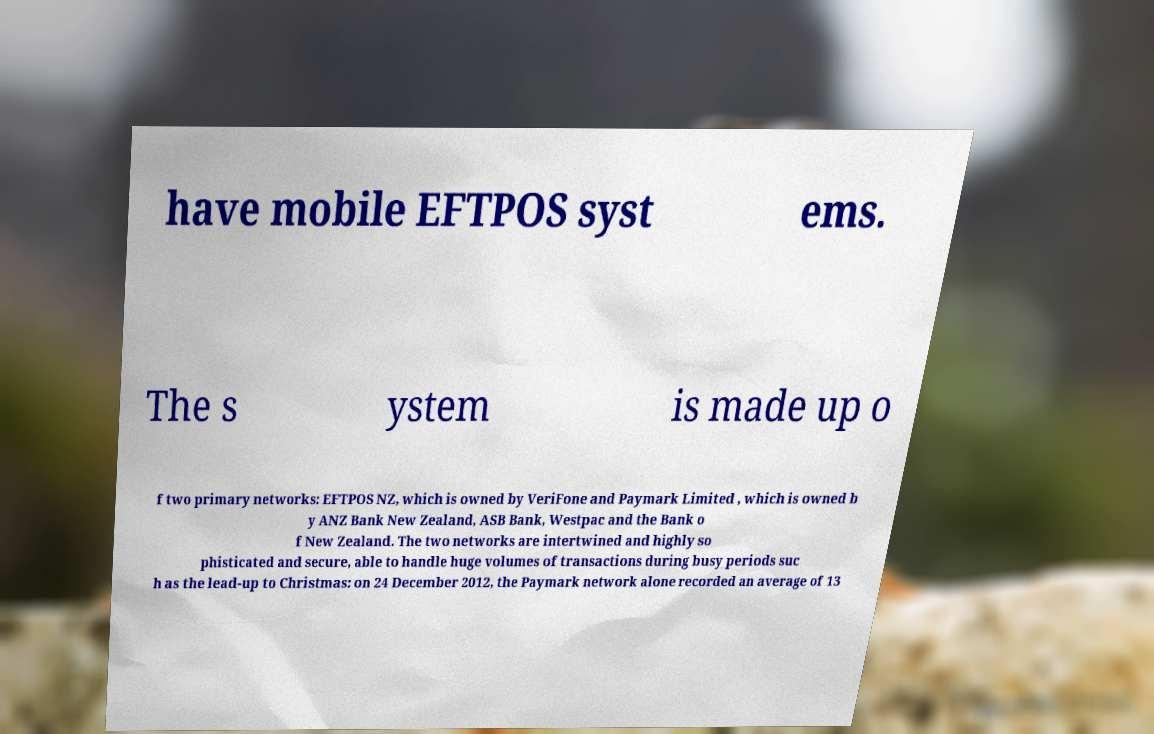Can you read and provide the text displayed in the image?This photo seems to have some interesting text. Can you extract and type it out for me? have mobile EFTPOS syst ems. The s ystem is made up o f two primary networks: EFTPOS NZ, which is owned by VeriFone and Paymark Limited , which is owned b y ANZ Bank New Zealand, ASB Bank, Westpac and the Bank o f New Zealand. The two networks are intertwined and highly so phisticated and secure, able to handle huge volumes of transactions during busy periods suc h as the lead-up to Christmas: on 24 December 2012, the Paymark network alone recorded an average of 13 